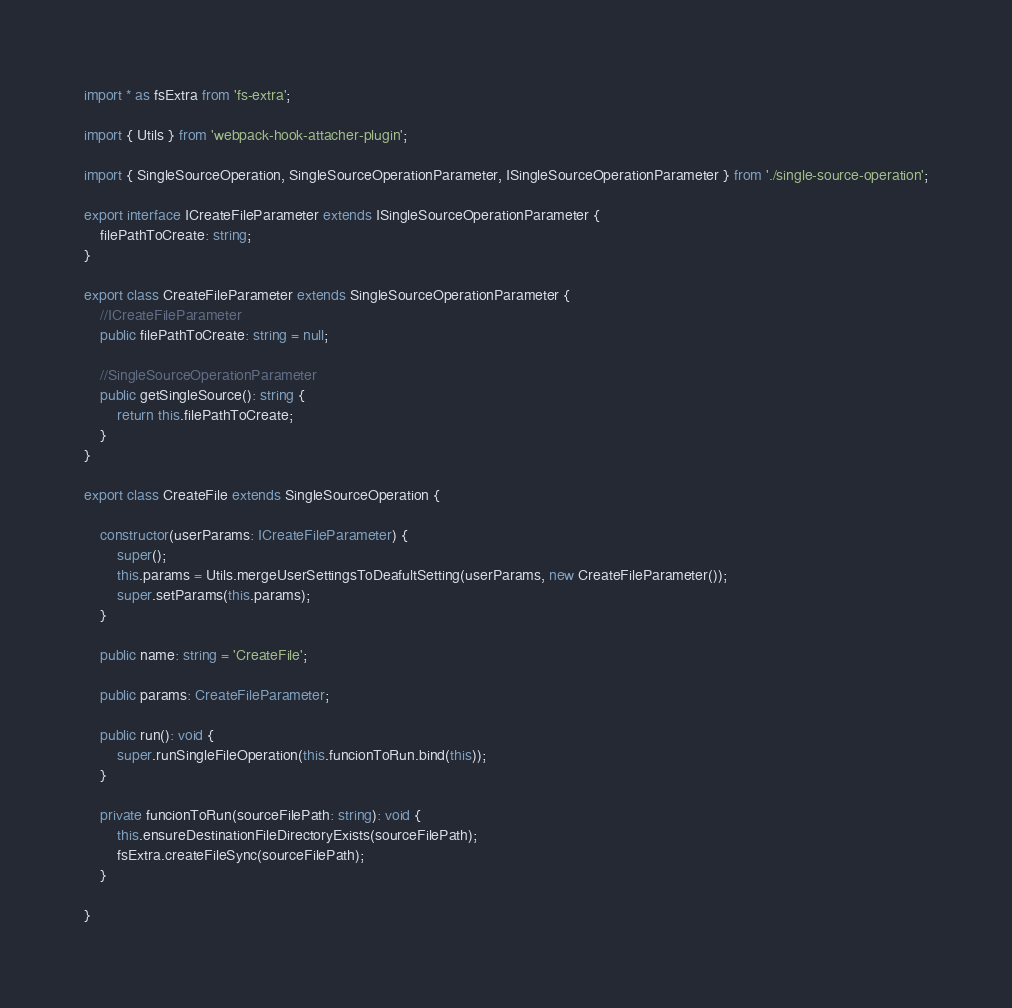<code> <loc_0><loc_0><loc_500><loc_500><_TypeScript_>import * as fsExtra from 'fs-extra';

import { Utils } from 'webpack-hook-attacher-plugin';

import { SingleSourceOperation, SingleSourceOperationParameter, ISingleSourceOperationParameter } from './single-source-operation';

export interface ICreateFileParameter extends ISingleSourceOperationParameter {
    filePathToCreate: string;
}

export class CreateFileParameter extends SingleSourceOperationParameter {
    //ICreateFileParameter
    public filePathToCreate: string = null;

    //SingleSourceOperationParameter
    public getSingleSource(): string {
        return this.filePathToCreate;
    }
}

export class CreateFile extends SingleSourceOperation {

    constructor(userParams: ICreateFileParameter) {
        super();
        this.params = Utils.mergeUserSettingsToDeafultSetting(userParams, new CreateFileParameter());
        super.setParams(this.params);
    }

    public name: string = 'CreateFile';

    public params: CreateFileParameter;

    public run(): void {
        super.runSingleFileOperation(this.funcionToRun.bind(this));
    }

    private funcionToRun(sourceFilePath: string): void {
        this.ensureDestinationFileDirectoryExists(sourceFilePath);
        fsExtra.createFileSync(sourceFilePath);
    }

}




</code> 